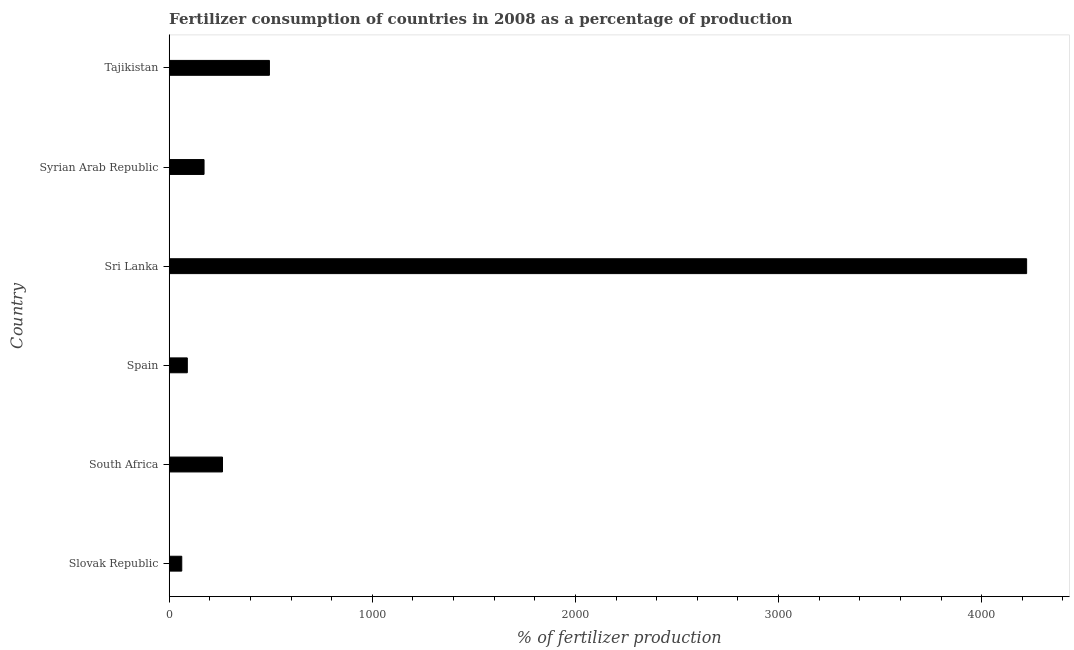Does the graph contain any zero values?
Offer a very short reply. No. Does the graph contain grids?
Your answer should be very brief. No. What is the title of the graph?
Offer a very short reply. Fertilizer consumption of countries in 2008 as a percentage of production. What is the label or title of the X-axis?
Provide a succinct answer. % of fertilizer production. What is the label or title of the Y-axis?
Provide a succinct answer. Country. What is the amount of fertilizer consumption in Sri Lanka?
Your answer should be compact. 4221.35. Across all countries, what is the maximum amount of fertilizer consumption?
Your answer should be very brief. 4221.35. Across all countries, what is the minimum amount of fertilizer consumption?
Keep it short and to the point. 61.84. In which country was the amount of fertilizer consumption maximum?
Make the answer very short. Sri Lanka. In which country was the amount of fertilizer consumption minimum?
Keep it short and to the point. Slovak Republic. What is the sum of the amount of fertilizer consumption?
Offer a terse response. 5299.69. What is the difference between the amount of fertilizer consumption in Slovak Republic and Spain?
Your response must be concise. -27.32. What is the average amount of fertilizer consumption per country?
Your answer should be compact. 883.28. What is the median amount of fertilizer consumption?
Provide a short and direct response. 216.97. In how many countries, is the amount of fertilizer consumption greater than 3600 %?
Your response must be concise. 1. What is the ratio of the amount of fertilizer consumption in Spain to that in Sri Lanka?
Offer a terse response. 0.02. Is the amount of fertilizer consumption in Slovak Republic less than that in Tajikistan?
Your answer should be compact. Yes. What is the difference between the highest and the second highest amount of fertilizer consumption?
Your answer should be very brief. 3727.97. Is the sum of the amount of fertilizer consumption in Sri Lanka and Tajikistan greater than the maximum amount of fertilizer consumption across all countries?
Give a very brief answer. Yes. What is the difference between the highest and the lowest amount of fertilizer consumption?
Offer a terse response. 4159.51. In how many countries, is the amount of fertilizer consumption greater than the average amount of fertilizer consumption taken over all countries?
Your response must be concise. 1. Are all the bars in the graph horizontal?
Offer a very short reply. Yes. What is the % of fertilizer production in Slovak Republic?
Provide a short and direct response. 61.84. What is the % of fertilizer production of South Africa?
Offer a very short reply. 262.37. What is the % of fertilizer production in Spain?
Your answer should be very brief. 89.17. What is the % of fertilizer production in Sri Lanka?
Provide a succinct answer. 4221.35. What is the % of fertilizer production in Syrian Arab Republic?
Your answer should be very brief. 171.57. What is the % of fertilizer production of Tajikistan?
Ensure brevity in your answer.  493.38. What is the difference between the % of fertilizer production in Slovak Republic and South Africa?
Offer a terse response. -200.52. What is the difference between the % of fertilizer production in Slovak Republic and Spain?
Make the answer very short. -27.32. What is the difference between the % of fertilizer production in Slovak Republic and Sri Lanka?
Your response must be concise. -4159.51. What is the difference between the % of fertilizer production in Slovak Republic and Syrian Arab Republic?
Provide a short and direct response. -109.73. What is the difference between the % of fertilizer production in Slovak Republic and Tajikistan?
Provide a short and direct response. -431.54. What is the difference between the % of fertilizer production in South Africa and Spain?
Give a very brief answer. 173.2. What is the difference between the % of fertilizer production in South Africa and Sri Lanka?
Offer a terse response. -3958.98. What is the difference between the % of fertilizer production in South Africa and Syrian Arab Republic?
Provide a short and direct response. 90.8. What is the difference between the % of fertilizer production in South Africa and Tajikistan?
Provide a short and direct response. -231.02. What is the difference between the % of fertilizer production in Spain and Sri Lanka?
Your answer should be very brief. -4132.18. What is the difference between the % of fertilizer production in Spain and Syrian Arab Republic?
Your answer should be very brief. -82.4. What is the difference between the % of fertilizer production in Spain and Tajikistan?
Offer a terse response. -404.21. What is the difference between the % of fertilizer production in Sri Lanka and Syrian Arab Republic?
Your answer should be compact. 4049.78. What is the difference between the % of fertilizer production in Sri Lanka and Tajikistan?
Give a very brief answer. 3727.97. What is the difference between the % of fertilizer production in Syrian Arab Republic and Tajikistan?
Offer a very short reply. -321.81. What is the ratio of the % of fertilizer production in Slovak Republic to that in South Africa?
Your response must be concise. 0.24. What is the ratio of the % of fertilizer production in Slovak Republic to that in Spain?
Give a very brief answer. 0.69. What is the ratio of the % of fertilizer production in Slovak Republic to that in Sri Lanka?
Your answer should be very brief. 0.01. What is the ratio of the % of fertilizer production in Slovak Republic to that in Syrian Arab Republic?
Give a very brief answer. 0.36. What is the ratio of the % of fertilizer production in Slovak Republic to that in Tajikistan?
Your response must be concise. 0.12. What is the ratio of the % of fertilizer production in South Africa to that in Spain?
Your answer should be very brief. 2.94. What is the ratio of the % of fertilizer production in South Africa to that in Sri Lanka?
Offer a very short reply. 0.06. What is the ratio of the % of fertilizer production in South Africa to that in Syrian Arab Republic?
Provide a succinct answer. 1.53. What is the ratio of the % of fertilizer production in South Africa to that in Tajikistan?
Your answer should be compact. 0.53. What is the ratio of the % of fertilizer production in Spain to that in Sri Lanka?
Make the answer very short. 0.02. What is the ratio of the % of fertilizer production in Spain to that in Syrian Arab Republic?
Offer a very short reply. 0.52. What is the ratio of the % of fertilizer production in Spain to that in Tajikistan?
Offer a terse response. 0.18. What is the ratio of the % of fertilizer production in Sri Lanka to that in Syrian Arab Republic?
Your answer should be very brief. 24.6. What is the ratio of the % of fertilizer production in Sri Lanka to that in Tajikistan?
Provide a short and direct response. 8.56. What is the ratio of the % of fertilizer production in Syrian Arab Republic to that in Tajikistan?
Provide a short and direct response. 0.35. 